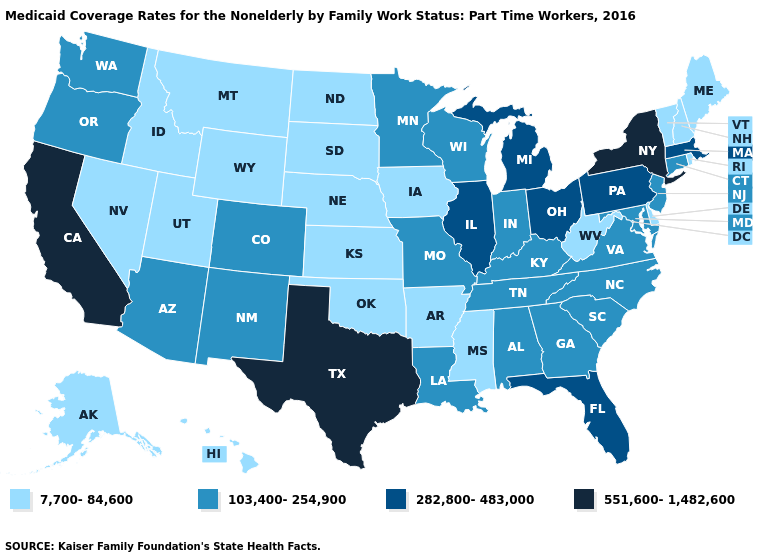Name the states that have a value in the range 551,600-1,482,600?
Give a very brief answer. California, New York, Texas. How many symbols are there in the legend?
Be succinct. 4. What is the value of Connecticut?
Write a very short answer. 103,400-254,900. What is the value of Tennessee?
Short answer required. 103,400-254,900. What is the highest value in the MidWest ?
Short answer required. 282,800-483,000. Among the states that border Georgia , does Florida have the highest value?
Short answer required. Yes. Among the states that border Indiana , does Michigan have the highest value?
Answer briefly. Yes. Does the map have missing data?
Give a very brief answer. No. What is the value of Kansas?
Keep it brief. 7,700-84,600. What is the lowest value in the USA?
Quick response, please. 7,700-84,600. Does Alabama have the lowest value in the South?
Answer briefly. No. What is the highest value in the USA?
Keep it brief. 551,600-1,482,600. Does New Hampshire have the highest value in the Northeast?
Short answer required. No. Does Alaska have a lower value than Mississippi?
Answer briefly. No. Name the states that have a value in the range 551,600-1,482,600?
Write a very short answer. California, New York, Texas. 